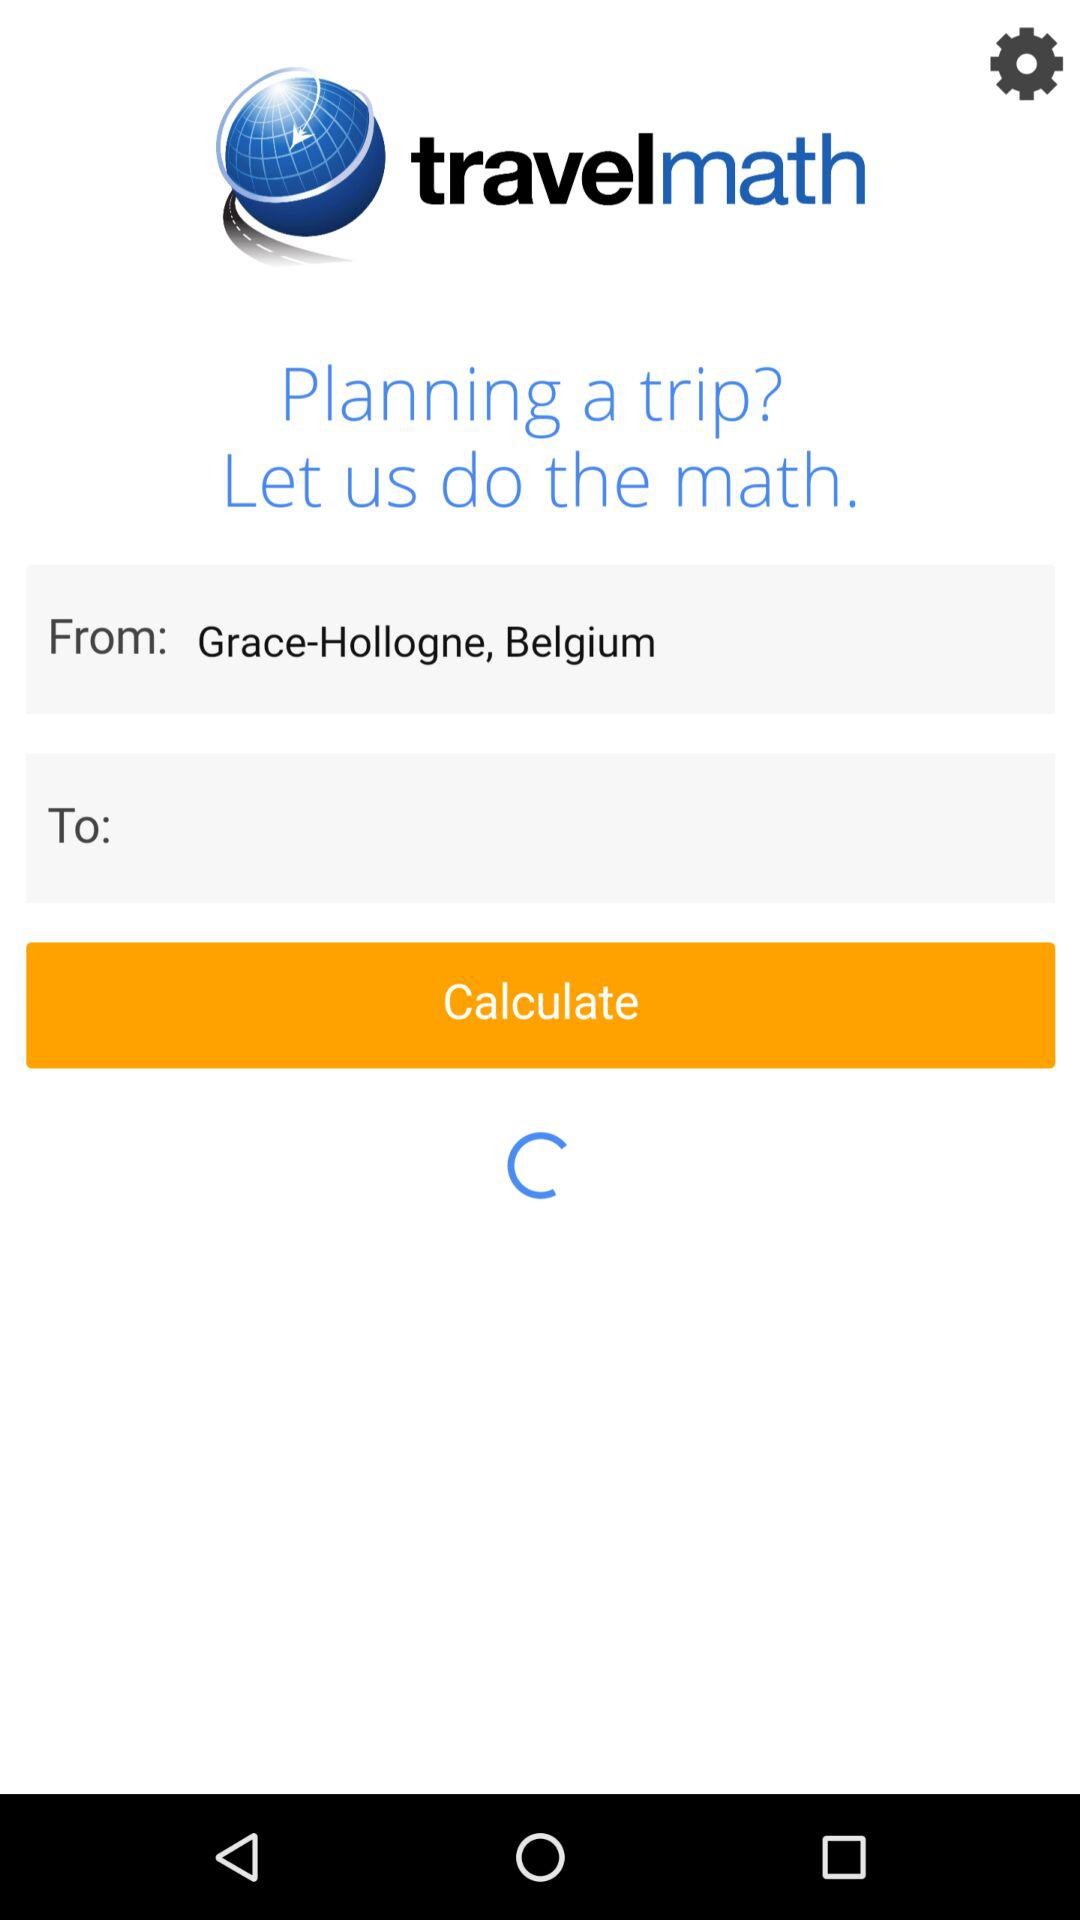What is the application name? The application name is "travelmath". 